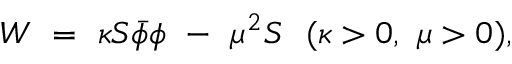<formula> <loc_0><loc_0><loc_500><loc_500>W \ = \ \kappa S \bar { \phi } \phi \ - \ \mu ^ { 2 } S \ \ ( \kappa > 0 , \ \mu > 0 ) ,</formula> 